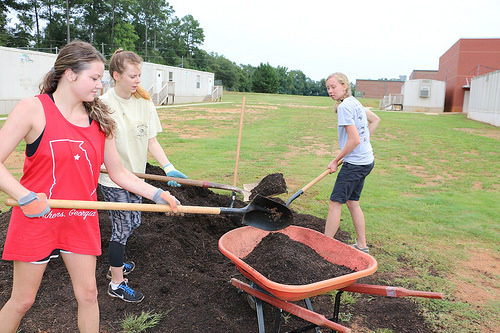<image>
Is there a girl on the shovel? No. The girl is not positioned on the shovel. They may be near each other, but the girl is not supported by or resting on top of the shovel. 